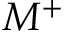Convert formula to latex. <formula><loc_0><loc_0><loc_500><loc_500>M ^ { + }</formula> 